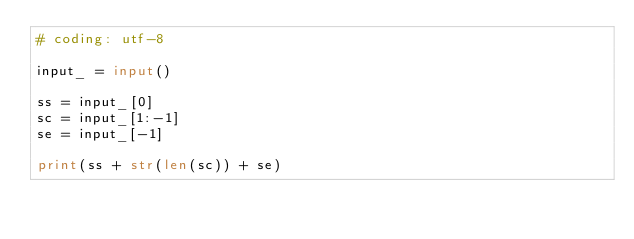<code> <loc_0><loc_0><loc_500><loc_500><_Python_># coding: utf-8

input_ = input()

ss = input_[0]
sc = input_[1:-1]
se = input_[-1]

print(ss + str(len(sc)) + se)
</code> 